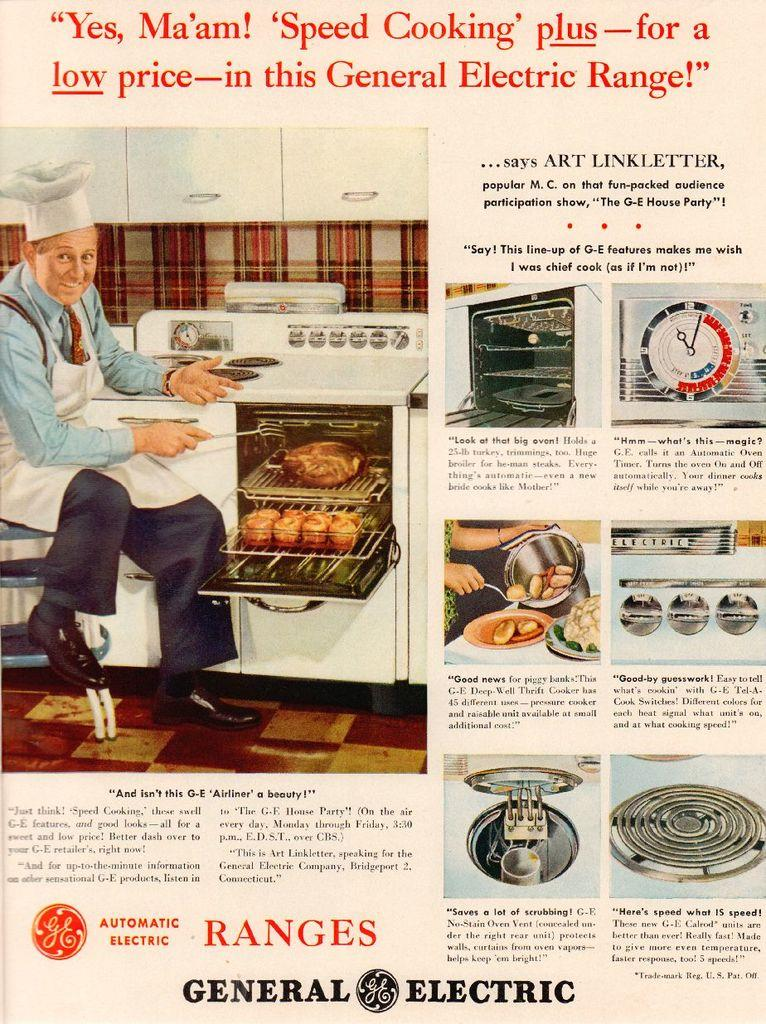<image>
Write a terse but informative summary of the picture. An advertisement for a General Electric oven range starts with the phrase "Yes, Ma'am!" 